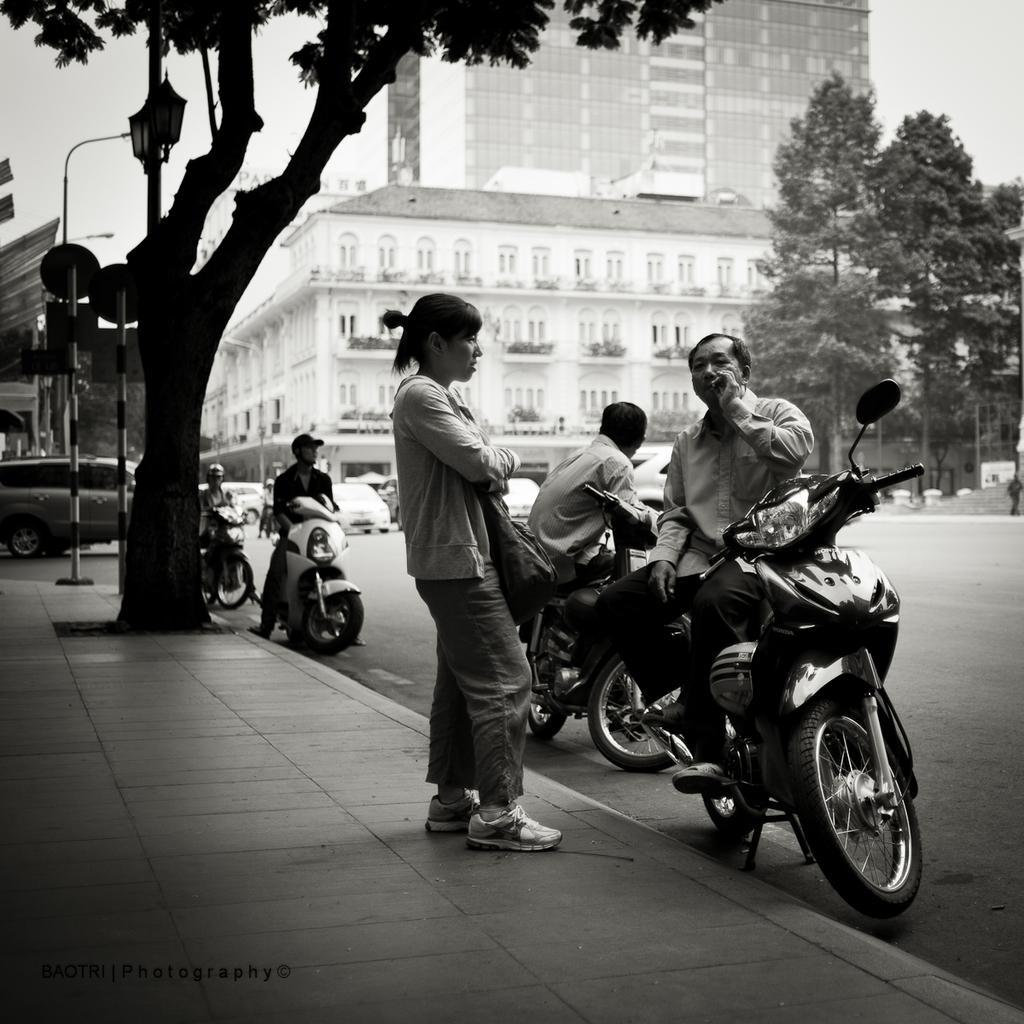How would you summarize this image in a sentence or two? As we can see in the image there are buildings, trees, few people here and there, cars and motorcycles. 